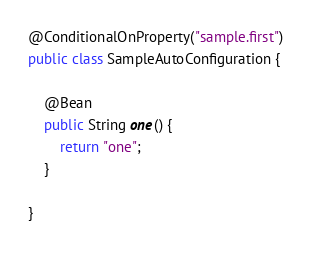Convert code to text. <code><loc_0><loc_0><loc_500><loc_500><_Java_>@ConditionalOnProperty("sample.first")
public class SampleAutoConfiguration {

	@Bean
	public String one() {
		return "one";
	}

}
</code> 